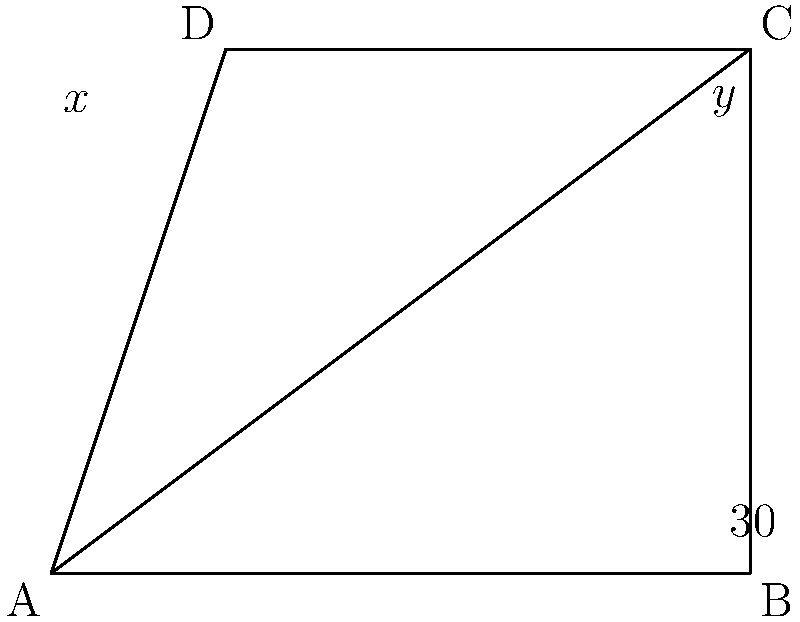In your latest geometric sculpture made from discarded wooden planks, you've created a quadrilateral ABCD with a diagonal AC. If angle BAC measures 30°, what are the measures of angles ACD ($x°$) and CAD ($y°$)? Let's approach this step-by-step:

1) In any quadrilateral, the sum of interior angles is 360°.

2) Triangle ABC is a right-angled triangle (we can see that BC is perpendicular to AB).

3) In triangle ABC:
   - Angle BAC = 30° (given)
   - Angle ABC = 90° (right angle)
   - Angle BCA = 180° - 90° - 30° = 60° (sum of angles in a triangle is 180°)

4) Now, let's focus on triangle ACD:
   - We know angle ACD ($x°$) and angle CAD ($y°$)
   - The third angle of this triangle is angle BCA, which we found to be 60°

5) Sum of angles in triangle ACD:
   $x° + y° + 60° = 180°$

6) We also know that $x° + y°$ + 30° + 90° = 360° (sum of angles in quadrilateral ABCD)

7) From step 6:
   $x° + y° = 360° - 120° = 240°$

8) Substituting this in the equation from step 5:
   $240° + 60° = 180°$

   This confirms our calculations so far.

9) We can't determine unique values for $x$ and $y$ with the given information. There are multiple possible combinations that satisfy $x + y = 240°$.
Answer: $x° + y° = 240°$ 